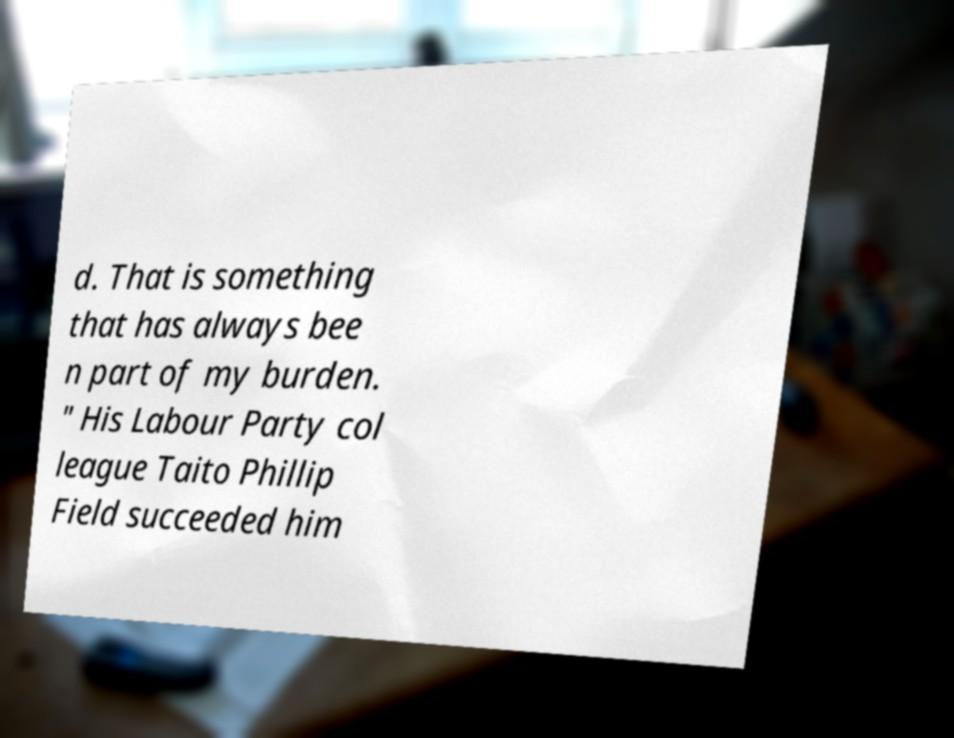Could you extract and type out the text from this image? d. That is something that has always bee n part of my burden. " His Labour Party col league Taito Phillip Field succeeded him 